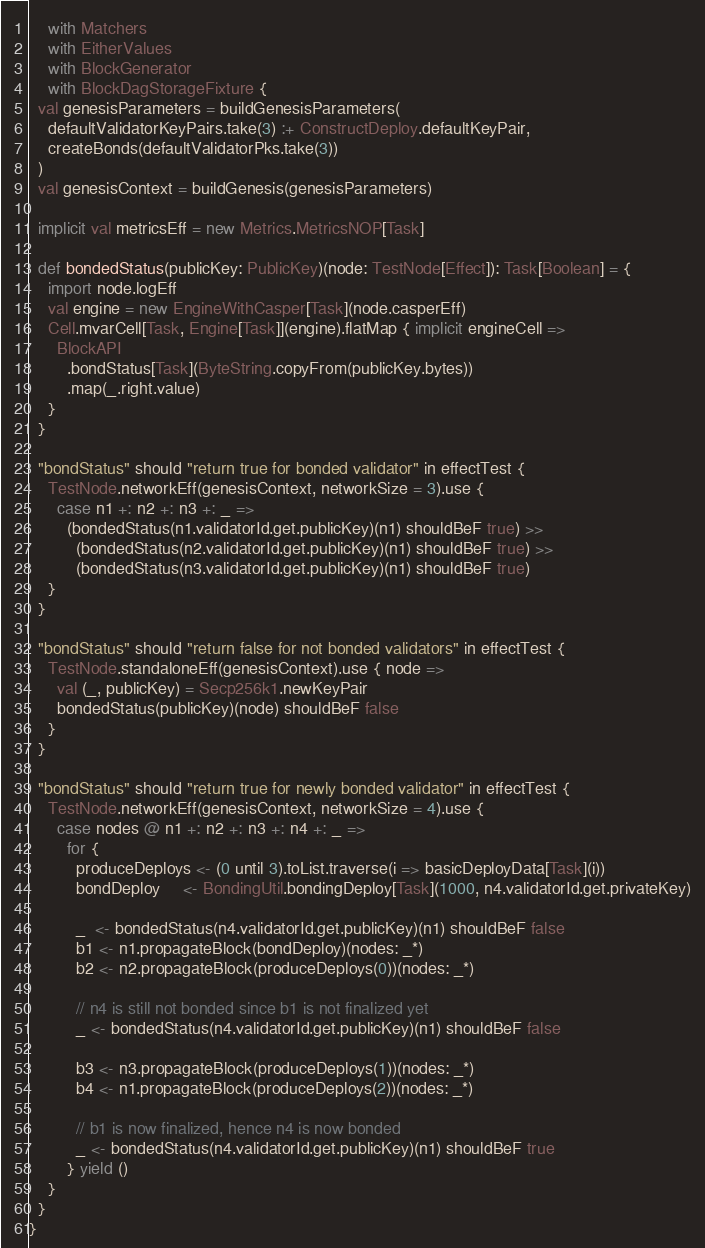Convert code to text. <code><loc_0><loc_0><loc_500><loc_500><_Scala_>    with Matchers
    with EitherValues
    with BlockGenerator
    with BlockDagStorageFixture {
  val genesisParameters = buildGenesisParameters(
    defaultValidatorKeyPairs.take(3) :+ ConstructDeploy.defaultKeyPair,
    createBonds(defaultValidatorPks.take(3))
  )
  val genesisContext = buildGenesis(genesisParameters)

  implicit val metricsEff = new Metrics.MetricsNOP[Task]

  def bondedStatus(publicKey: PublicKey)(node: TestNode[Effect]): Task[Boolean] = {
    import node.logEff
    val engine = new EngineWithCasper[Task](node.casperEff)
    Cell.mvarCell[Task, Engine[Task]](engine).flatMap { implicit engineCell =>
      BlockAPI
        .bondStatus[Task](ByteString.copyFrom(publicKey.bytes))
        .map(_.right.value)
    }
  }

  "bondStatus" should "return true for bonded validator" in effectTest {
    TestNode.networkEff(genesisContext, networkSize = 3).use {
      case n1 +: n2 +: n3 +: _ =>
        (bondedStatus(n1.validatorId.get.publicKey)(n1) shouldBeF true) >>
          (bondedStatus(n2.validatorId.get.publicKey)(n1) shouldBeF true) >>
          (bondedStatus(n3.validatorId.get.publicKey)(n1) shouldBeF true)
    }
  }

  "bondStatus" should "return false for not bonded validators" in effectTest {
    TestNode.standaloneEff(genesisContext).use { node =>
      val (_, publicKey) = Secp256k1.newKeyPair
      bondedStatus(publicKey)(node) shouldBeF false
    }
  }

  "bondStatus" should "return true for newly bonded validator" in effectTest {
    TestNode.networkEff(genesisContext, networkSize = 4).use {
      case nodes @ n1 +: n2 +: n3 +: n4 +: _ =>
        for {
          produceDeploys <- (0 until 3).toList.traverse(i => basicDeployData[Task](i))
          bondDeploy     <- BondingUtil.bondingDeploy[Task](1000, n4.validatorId.get.privateKey)

          _  <- bondedStatus(n4.validatorId.get.publicKey)(n1) shouldBeF false
          b1 <- n1.propagateBlock(bondDeploy)(nodes: _*)
          b2 <- n2.propagateBlock(produceDeploys(0))(nodes: _*)

          // n4 is still not bonded since b1 is not finalized yet
          _ <- bondedStatus(n4.validatorId.get.publicKey)(n1) shouldBeF false

          b3 <- n3.propagateBlock(produceDeploys(1))(nodes: _*)
          b4 <- n1.propagateBlock(produceDeploys(2))(nodes: _*)

          // b1 is now finalized, hence n4 is now bonded
          _ <- bondedStatus(n4.validatorId.get.publicKey)(n1) shouldBeF true
        } yield ()
    }
  }
}
</code> 